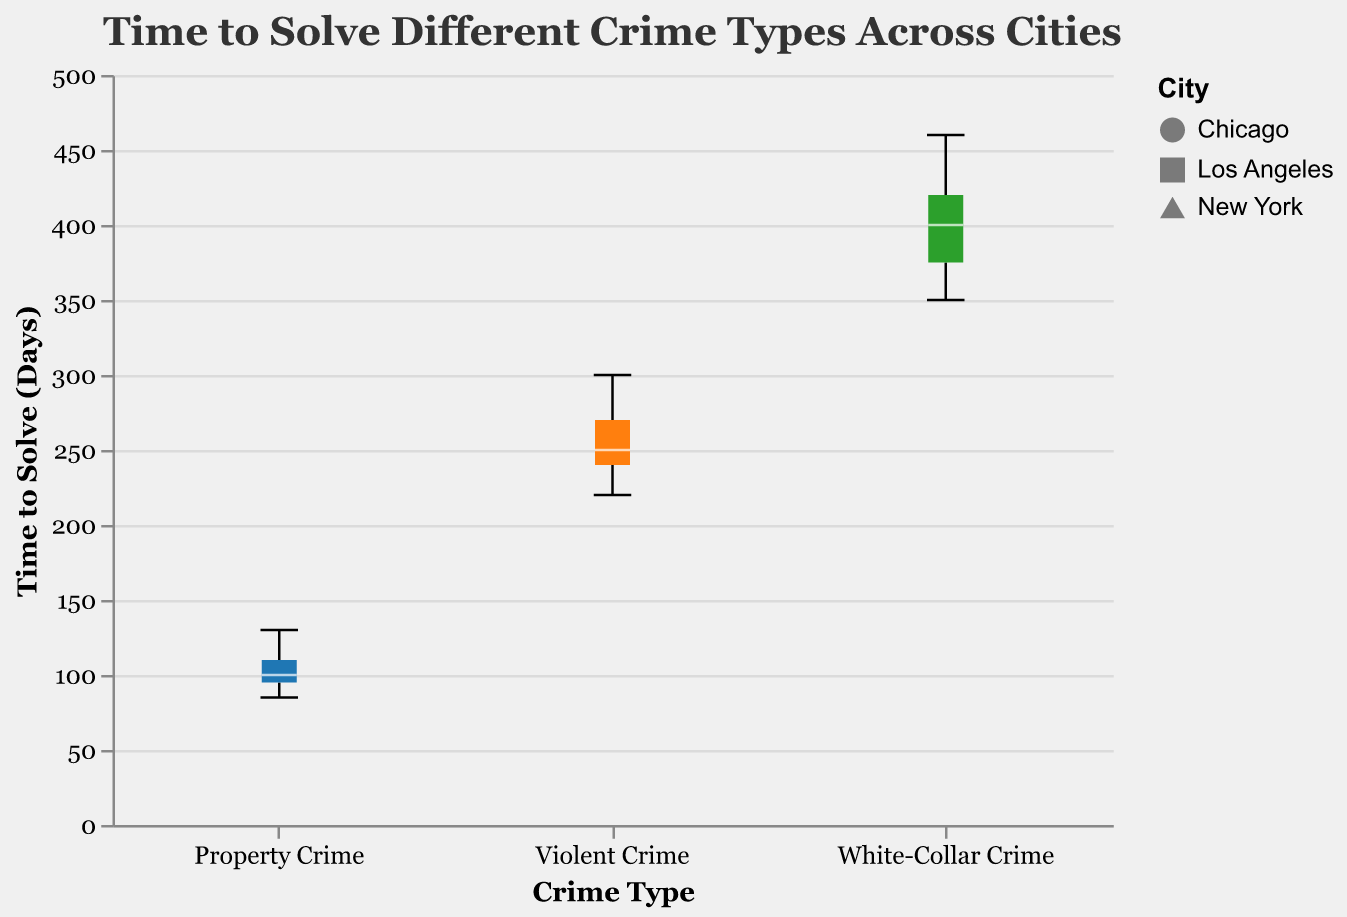What's the title of the figure? The title of the figure is located at the top and states the overall purpose of the visualization.
Answer: Time to Solve Different Crime Types Across Cities Which crime type has the shortest median time to solve? By examining the median lines within each box plot—typically represented by a horizontal line—the shortest median time is observed in Property Crimes.
Answer: Property Crime What is the range of time taken to solve violent crimes in Los Angeles? The range represents the difference between the maximum and minimum values within the box plot of Violent Crime for the city of Los Angeles.
Answer: 220 to 260 days How many data points represent the time taken to solve property crimes in Chicago? Each individual point scattered over the box plot for Property Crimes in the Chicago category represents one data point. By counting these, we get the total number.
Answer: 3 Which city shows the longest time to solve white-collar crimes? By comparing the upper extremities of the box plots for White-Collar Crime across all cities, we can identify the city with the longest time.
Answer: Chicago Compare the median time taken to solve violent crimes between New York and Chicago. Which is greater? The median lines within the box plots for Violent Crime in both New York and Chicago are compared, and the line in New York is higher, indicating a greater median time.
Answer: New York What is the interquartile range (IQR) for property crimes in Los Angeles? IQR is the difference between the first and third quartiles. In the box plot for Property Crimes in Los Angeles, this can be estimated by examining the box height. If the first quartile is around 85 days and the third quartile around 110 days, the IQR is 110 - 85.
Answer: 25 days Are there any outliers in the time taken to solve violent crimes in any city? Outliers in a box plot are typically points that lie outside the whiskers. Checking the Violent Crime category for any points lying beyond the whiskers’ extent provides the answer.
Answer: No How does the scatter point distribution for white-collar crimes vary across the cities? By observing the position and spread of the scatter points in the White-Collar Crime category, we can infer the distribution patterns.
Answer: New York and Chicago have a wider distribution with higher times compared to Los Angeles Which city shows the least variation in solving time for property crimes? Variation can be assessed by the height of the box plot (IQR) and the length of the whiskers. The shorter these are, the lesser the variation. By comparing Property Crime box plots for all cities, Los Angeles exhibits the least variation.
Answer: Los Angeles 